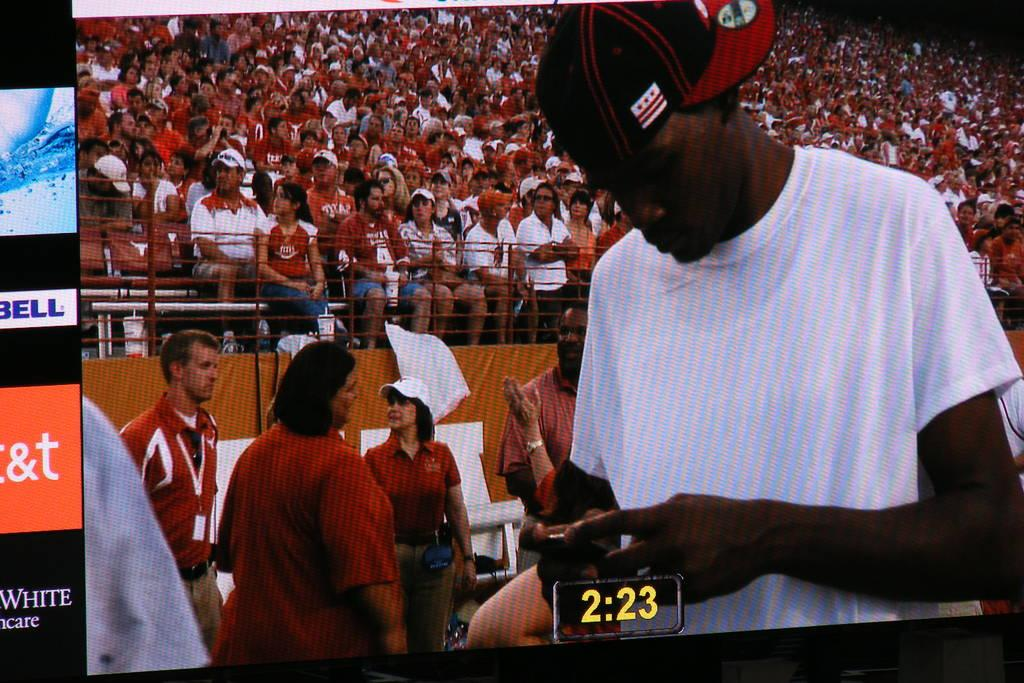<image>
Render a clear and concise summary of the photo. The time on the TV screen is 2:23. 